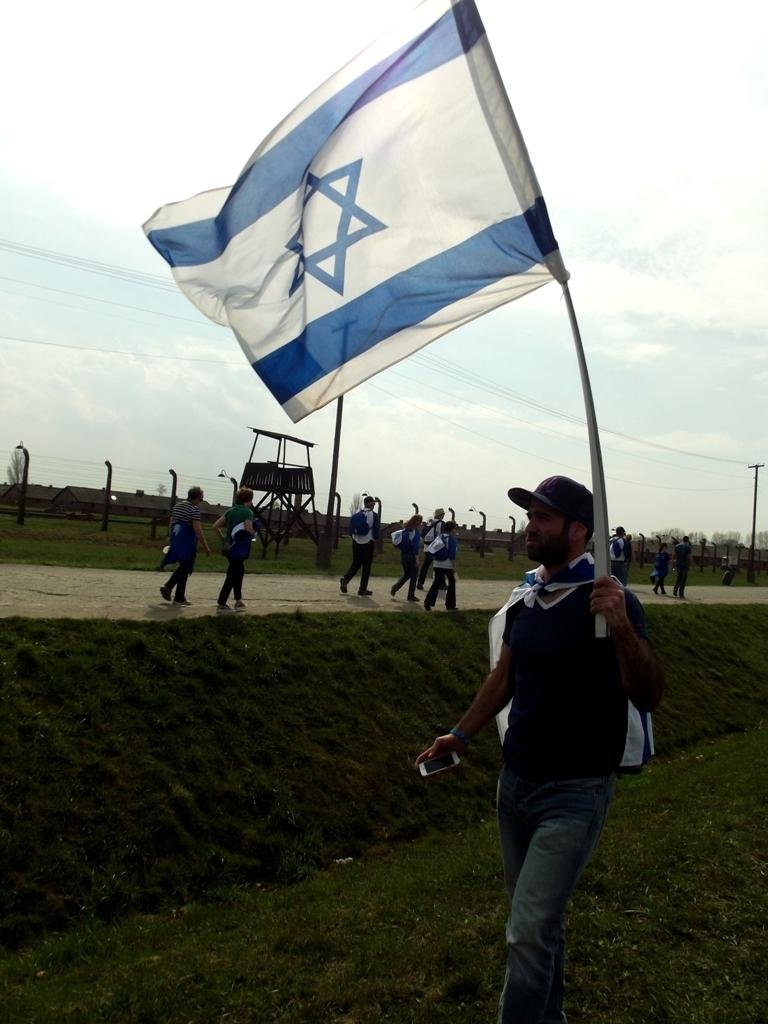How many people are in the image? There are people in the image, but the exact number is not specified. What is the man holding in the image? The man is holding a flag in the image. What can be seen in the background of the image? In the background of the image, there is a fence, poles, and the sky. What type of terrain is visible in the image? There is grass in the image, indicating a grassy terrain. What type of pathway is present in the image? There is a road in the image. Can you see a loaf of bread being shared between the people in the image? There is no mention of bread or any food item in the image. The focus is on the people, the man holding the flag, and the background elements. 